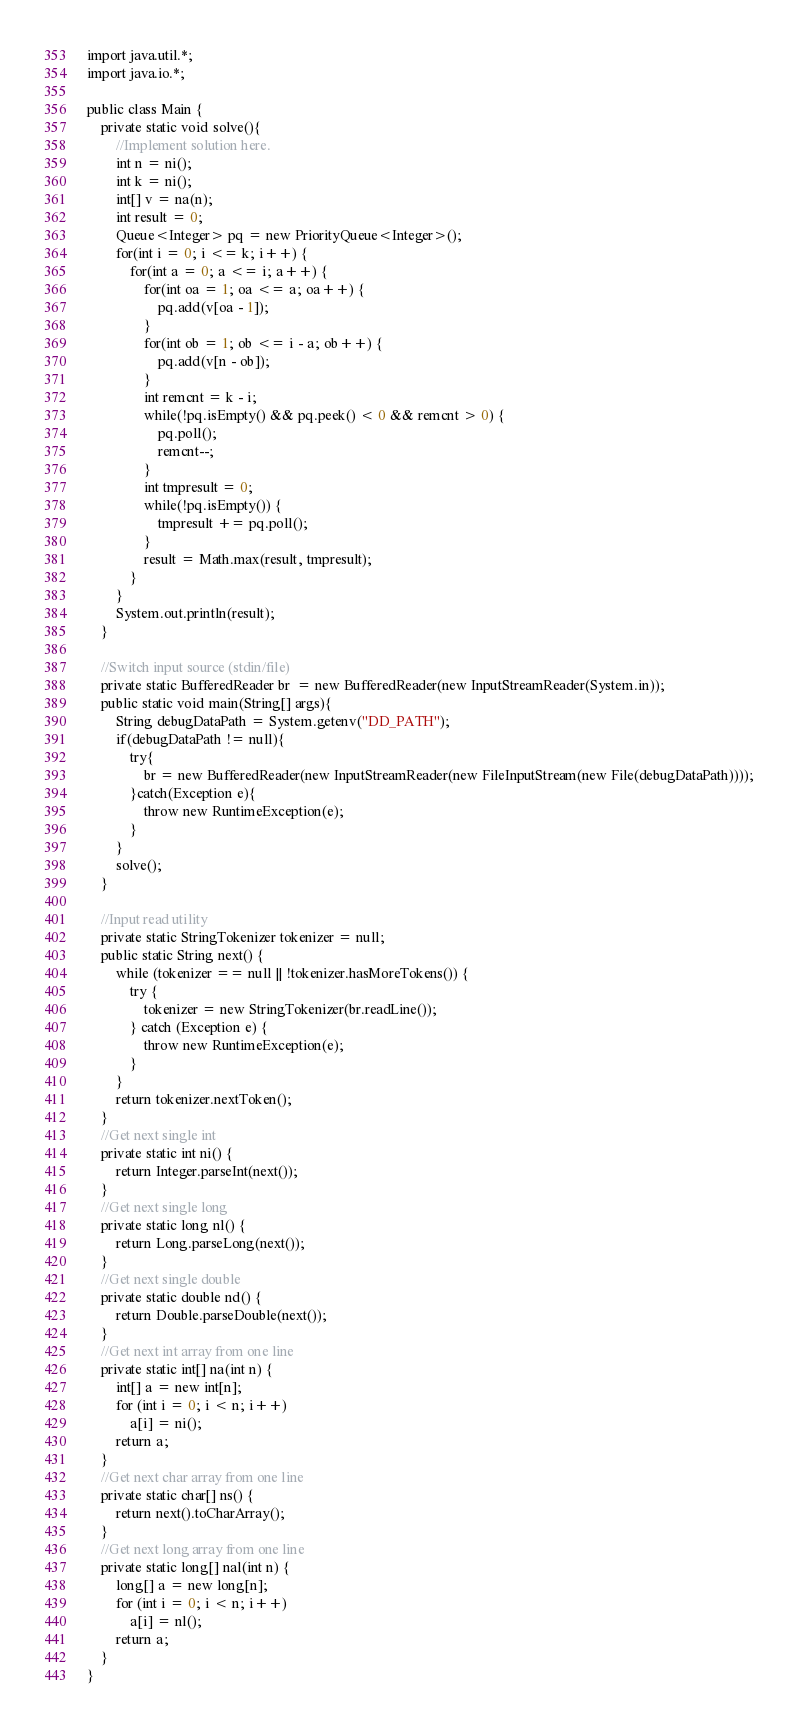Convert code to text. <code><loc_0><loc_0><loc_500><loc_500><_Java_>import java.util.*;
import java.io.*;

public class Main {
	private static void solve(){
		//Implement solution here.
		int n = ni();
		int k = ni();
		int[] v = na(n);
		int result = 0;
		Queue<Integer> pq = new PriorityQueue<Integer>();
		for(int i = 0; i <= k; i++) {
			for(int a = 0; a <= i; a++) {				
				for(int oa = 1; oa <= a; oa++) {
					pq.add(v[oa - 1]);
				}				
				for(int ob = 1; ob <= i - a; ob++) {
					pq.add(v[n - ob]);
				}				
				int remcnt = k - i;
				while(!pq.isEmpty() && pq.peek() < 0 && remcnt > 0) {
					pq.poll();
					remcnt--;
				}
				int tmpresult = 0;
				while(!pq.isEmpty()) {
					tmpresult += pq.poll();
				}
				result = Math.max(result, tmpresult);
			}	
		}
		System.out.println(result);		
	}

	//Switch input source (stdin/file)
	private static BufferedReader br  = new BufferedReader(new InputStreamReader(System.in));
	public static void main(String[] args){
		String debugDataPath = System.getenv("DD_PATH");        
		if(debugDataPath != null){
			try{
				br = new BufferedReader(new InputStreamReader(new FileInputStream(new File(debugDataPath))));
			}catch(Exception e){
				throw new RuntimeException(e);
			}
		}
		solve();
	}

	//Input read utility
	private static StringTokenizer tokenizer = null;
	public static String next() {
		while (tokenizer == null || !tokenizer.hasMoreTokens()) {
			try {
				tokenizer = new StringTokenizer(br.readLine());
			} catch (Exception e) {
				throw new RuntimeException(e);
			}
		}
		return tokenizer.nextToken();
	}
	//Get next single int
	private static int ni() {
		return Integer.parseInt(next());
	}
	//Get next single long
	private static long nl() {
		return Long.parseLong(next());
	}
	//Get next single double
	private static double nd() {
		return Double.parseDouble(next());
	}
	//Get next int array from one line
	private static int[] na(int n) {
		int[] a = new int[n];
		for (int i = 0; i < n; i++)
			a[i] = ni();
		return a;
	}
	//Get next char array from one line
	private static char[] ns() {
		return next().toCharArray();
	}
	//Get next long array from one line
	private static long[] nal(int n) {
		long[] a = new long[n];
		for (int i = 0; i < n; i++)
			a[i] = nl();
		return a;
	}
}</code> 